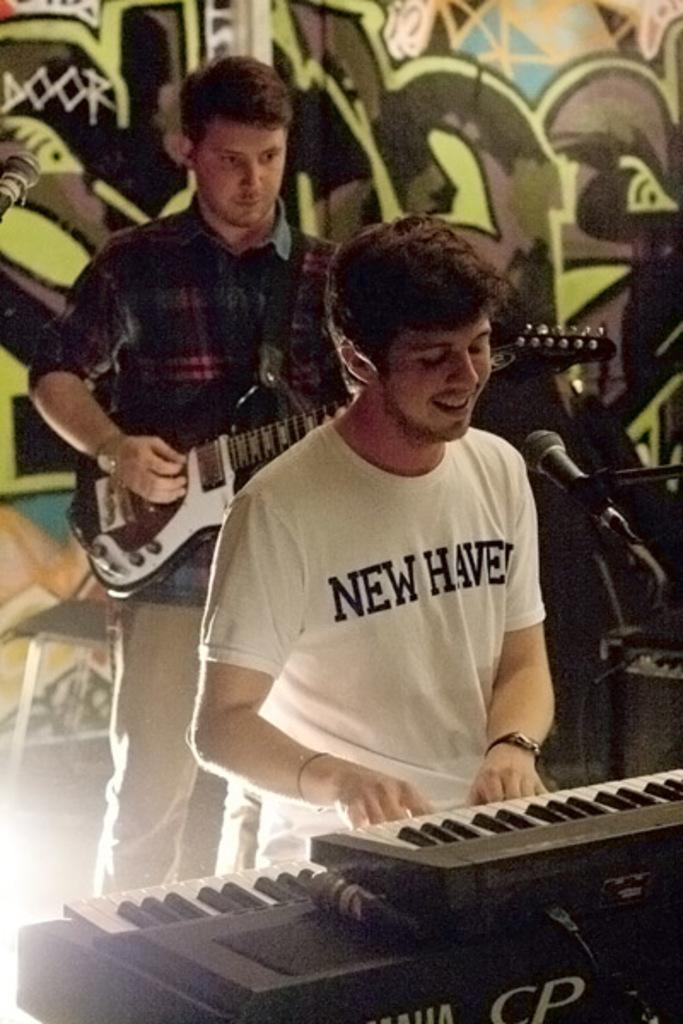How many people are in the image? There are two persons in the image. What are the people doing in the image? One person is standing and playing a guitar, while another person is sitting and playing a piano. What object is in front of the person playing the piano? There is a microphone in front of the person playing the piano. What type of brass instrument can be seen in the image? There is no brass instrument present in the image. 